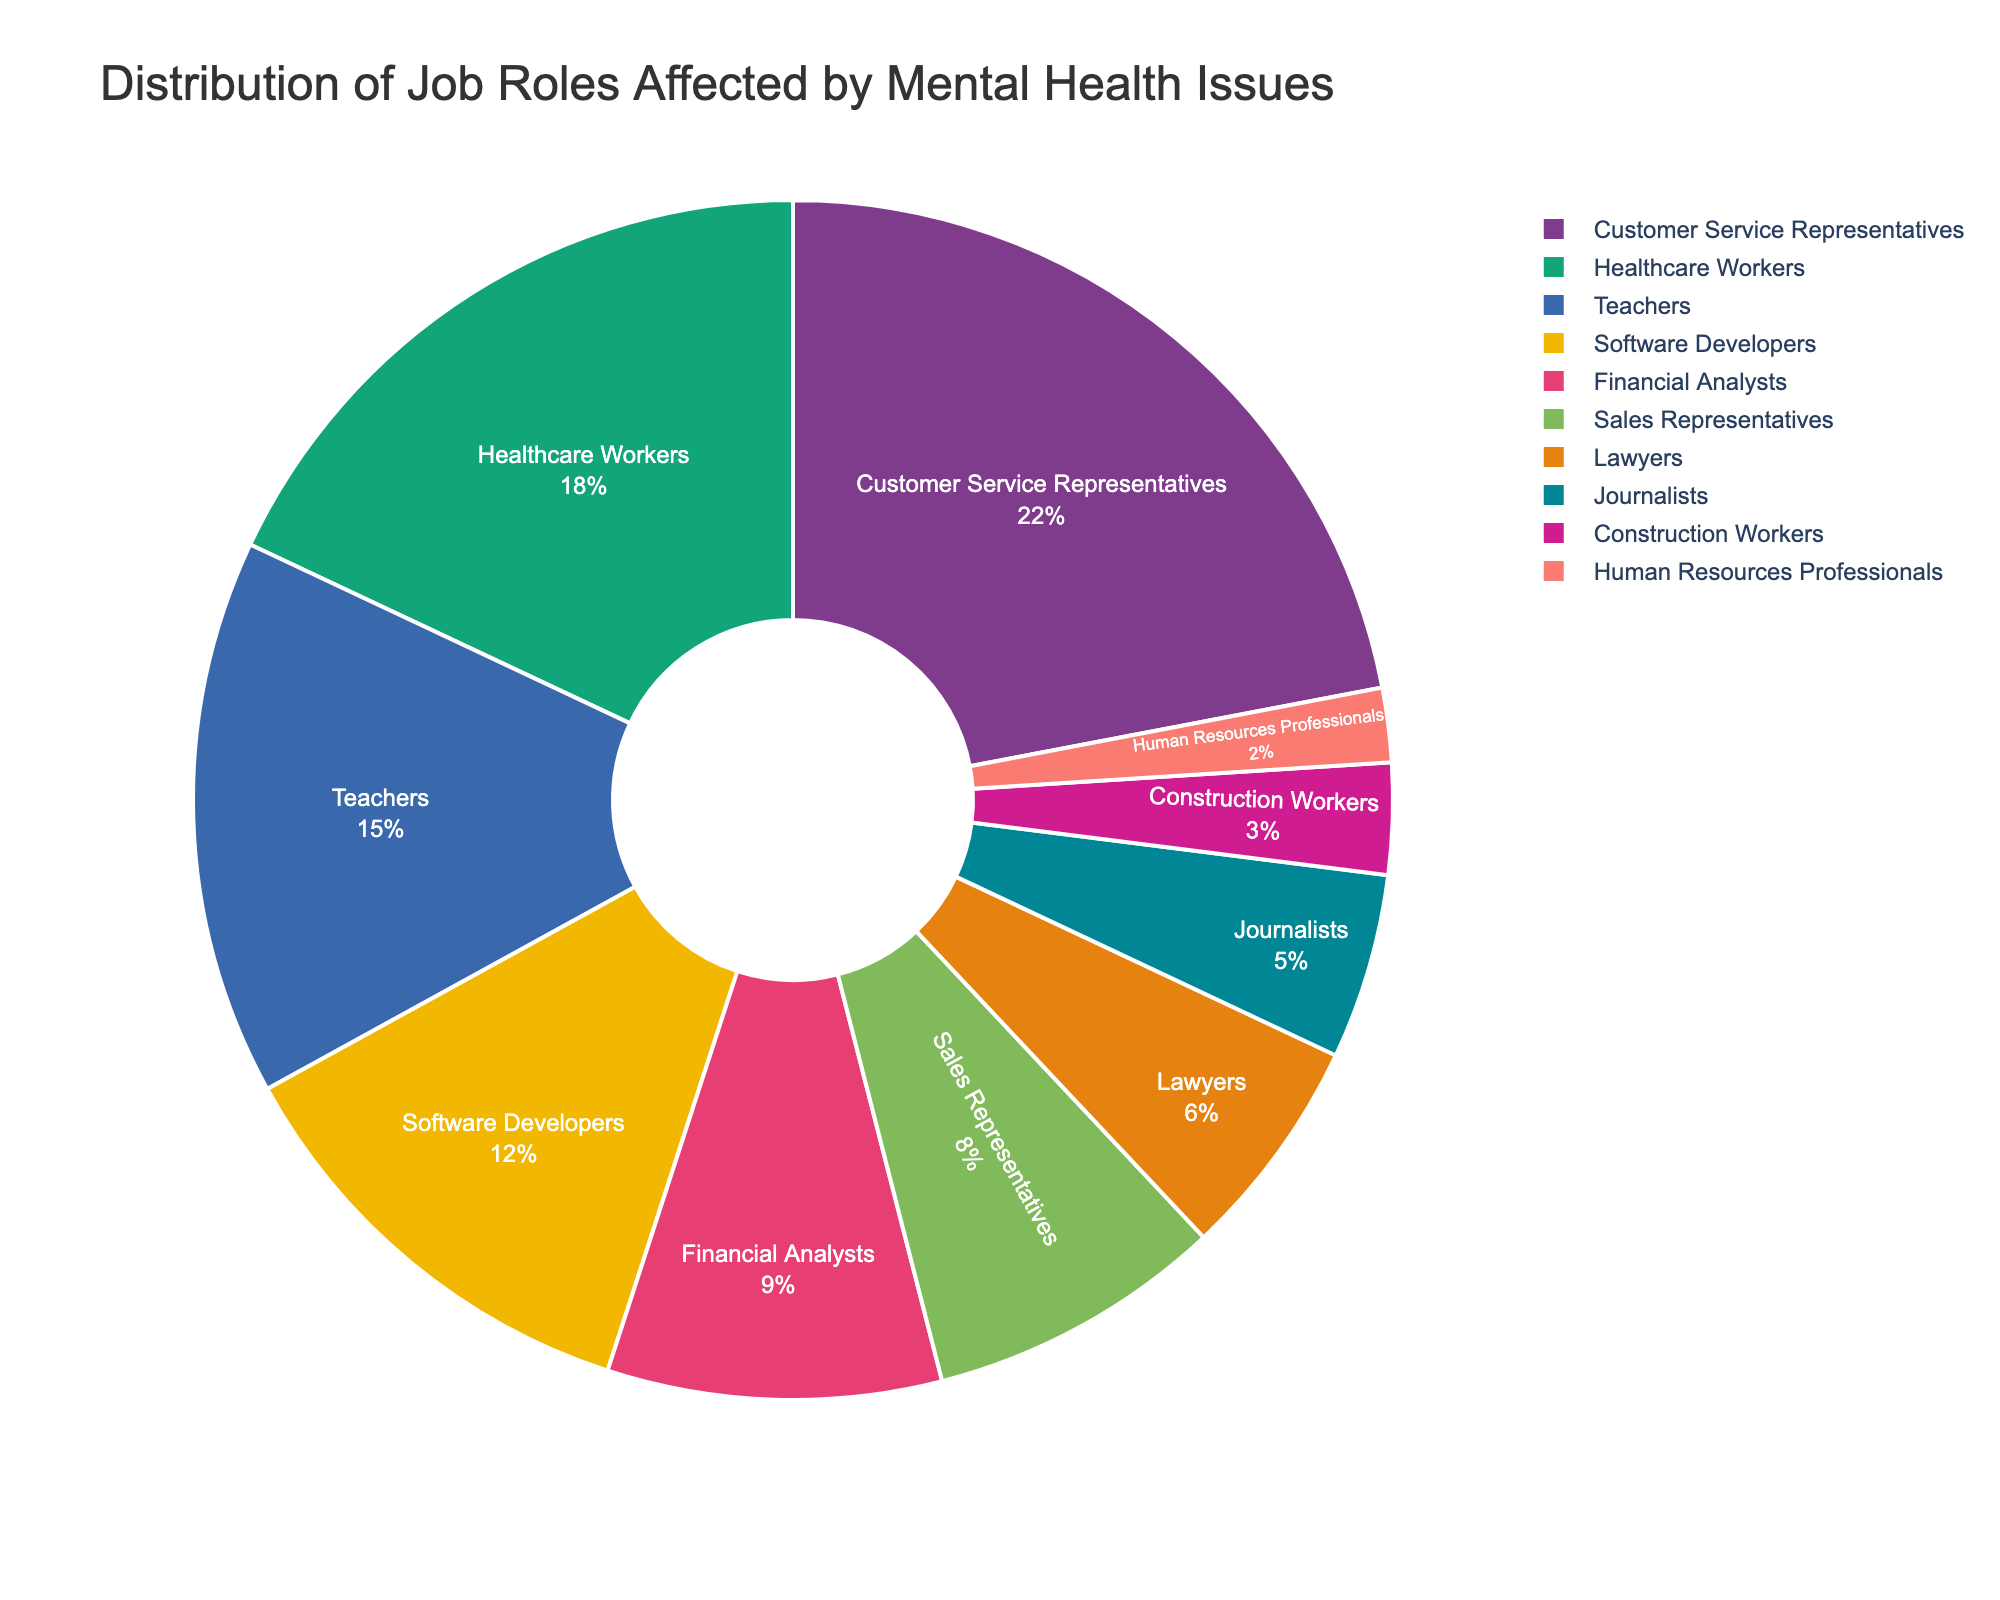What job role is most affected by mental health issues according to the chart? Customer Service Representatives have the largest segment in the pie chart. Their percentage is the highest among all the job roles listed.
Answer: Customer Service Representatives How much more affected are Teachers compared to Journalists? Teachers have 15% while Journalists have 5%. The difference is calculated by subtracting 5% from 15%.
Answer: 10% What is the combined percentage of Healthcare Workers and Software Developers affected by mental health issues? Healthcare Workers have 18% and Software Developers have 12%. Adding these together gives the combined percentage.
Answer: 30% Which job roles have a smaller percentage of mental health issues than Sales Representatives? Sales Representatives have 8%. Comparing this with the other percentages, smaller percentages are for Lawyers (6%), Journalists (5%), Construction Workers (3%), and Human Resources Professionals (2%).
Answer: Lawyers, Journalists, Construction Workers, Human Resources Professionals By how much does the percentage of Financial Analysts exceed that of Construction Workers? Financial Analysts have 9% while Construction Workers have 3%. The difference is calculated by subtracting 3% from 9%.
Answer: 6% Which two job roles together account for nearly half of the pie chart? Customer Service Representatives have 22% and Healthcare Workers have 18%. Adding these together gives 40%, which is nearly half of the pie chart.
Answer: Customer Service Representatives, Healthcare Workers What percentage of the chart is made up of roles other than Customer Service Representatives and Healthcare Workers? Customer Service Representatives have 22% and Healthcare Workers have 18%. Subtract their combined percentage from 100%: 100% - (22% + 18%) = 60%.
Answer: 60% If you combined the percentages of Software Developers, Financial Analysts, and Sales Representatives, how does this compare to the percentage of Customer Service Representatives? The combined percentage of Software Developers (12%), Financial Analysts (9%), and Sales Representatives (8%) is 12% + 9% + 8% = 29%. Customer Service Representatives have 22%. 29% is greater than 22%.
Answer: 29% > 22% What is the visual indication that Customer Service Representatives are most affected? The segment representing Customer Service Representatives is the largest in size, making it visually the most prominent part of the pie chart.
Answer: Largest segment How do the percentages of Teachers and Sales Representatives compare, and what is their difference? Teachers have 15% and Sales Representatives have 8%. The difference is calculated by subtracting 8% from 15%.
Answer: 7% 